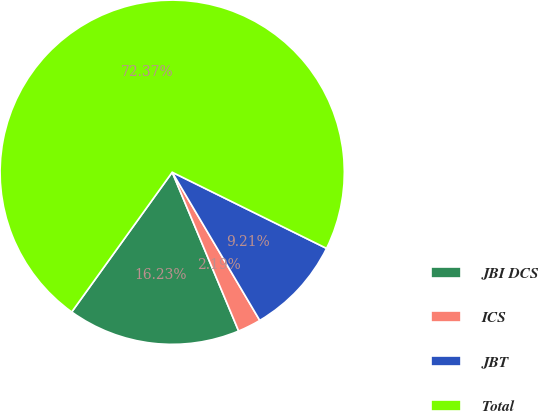<chart> <loc_0><loc_0><loc_500><loc_500><pie_chart><fcel>JBI DCS<fcel>ICS<fcel>JBT<fcel>Total<nl><fcel>16.23%<fcel>2.19%<fcel>9.21%<fcel>72.38%<nl></chart> 